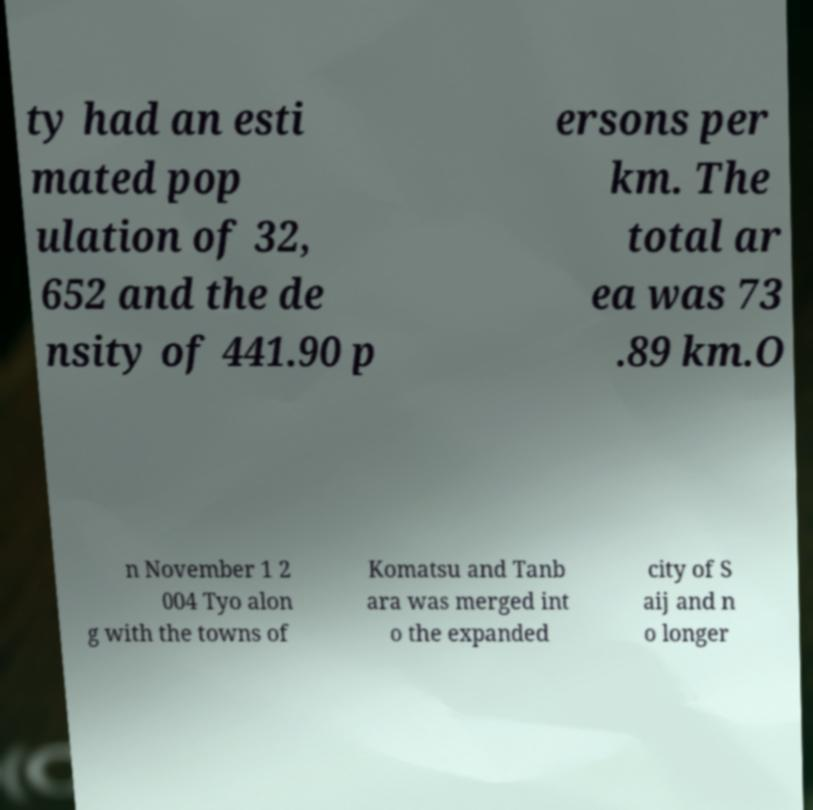I need the written content from this picture converted into text. Can you do that? ty had an esti mated pop ulation of 32, 652 and the de nsity of 441.90 p ersons per km. The total ar ea was 73 .89 km.O n November 1 2 004 Tyo alon g with the towns of Komatsu and Tanb ara was merged int o the expanded city of S aij and n o longer 